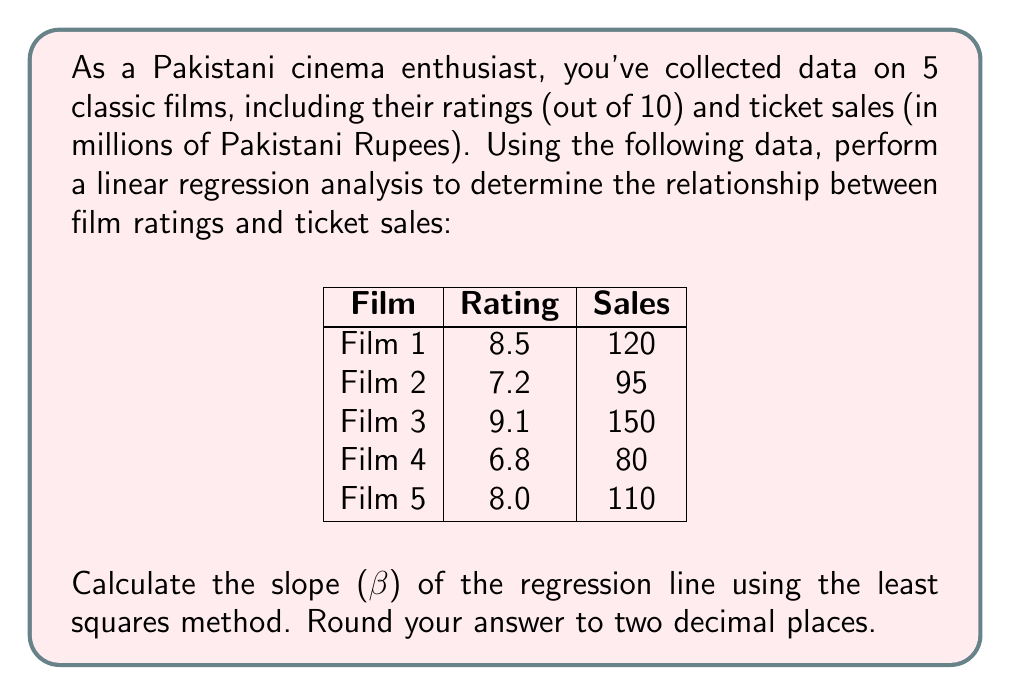Show me your answer to this math problem. To calculate the slope (β) of the regression line using the least squares method, we'll follow these steps:

1. Let x represent the ratings and y represent the sales.

2. Calculate the means of x and y:
   $\bar{x} = \frac{8.5 + 7.2 + 9.1 + 6.8 + 8.0}{5} = 7.92$
   $\bar{y} = \frac{120 + 95 + 150 + 80 + 110}{5} = 111$

3. Calculate the following sums:
   $\sum(x - \bar{x})(y - \bar{y})$ and $\sum(x - \bar{x})^2$

   $\sum(x - \bar{x})(y - \bar{y}) = (8.5 - 7.92)(120 - 111) + (7.2 - 7.92)(95 - 111) + (9.1 - 7.92)(150 - 111) + (6.8 - 7.92)(80 - 111) + (8.0 - 7.92)(110 - 111)$
   $= 0.58 \cdot 9 + (-0.72) \cdot (-16) + 1.18 \cdot 39 + (-1.12) \cdot (-31) + 0.08 \cdot (-1)$
   $= 5.22 + 11.52 + 46.02 + 34.72 - 0.08 = 97.40$

   $\sum(x - \bar{x})^2 = (8.5 - 7.92)^2 + (7.2 - 7.92)^2 + (9.1 - 7.92)^2 + (6.8 - 7.92)^2 + (8.0 - 7.92)^2$
   $= 0.58^2 + (-0.72)^2 + 1.18^2 + (-1.12)^2 + 0.08^2$
   $= 0.3364 + 0.5184 + 1.3924 + 1.2544 + 0.0064 = 3.5080$

4. Calculate the slope (β) using the formula:
   $$\beta = \frac{\sum(x - \bar{x})(y - \bar{y})}{\sum(x - \bar{x})^2}$$

   $$\beta = \frac{97.40}{3.5080} = 27.76$$

5. Round the result to two decimal places: 27.76
Answer: 27.76 